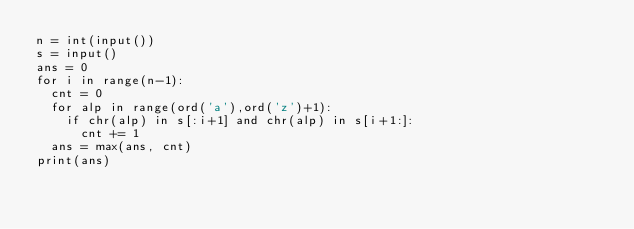<code> <loc_0><loc_0><loc_500><loc_500><_Python_>n = int(input())
s = input()
ans = 0
for i in range(n-1):
  cnt = 0
  for alp in range(ord('a'),ord('z')+1):
    if chr(alp) in s[:i+1] and chr(alp) in s[i+1:]:
      cnt += 1
  ans = max(ans, cnt)
print(ans)
</code> 